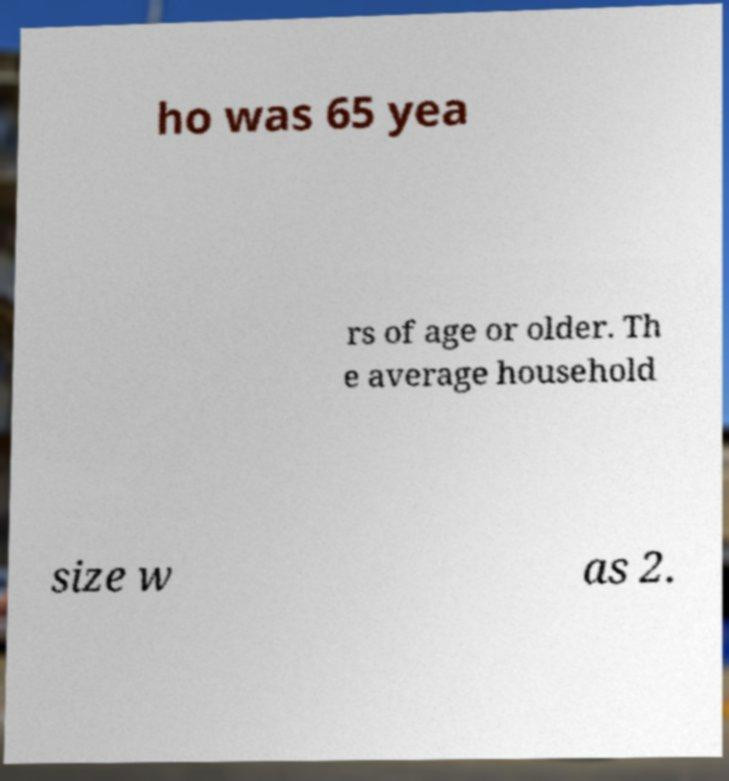Can you read and provide the text displayed in the image?This photo seems to have some interesting text. Can you extract and type it out for me? ho was 65 yea rs of age or older. Th e average household size w as 2. 